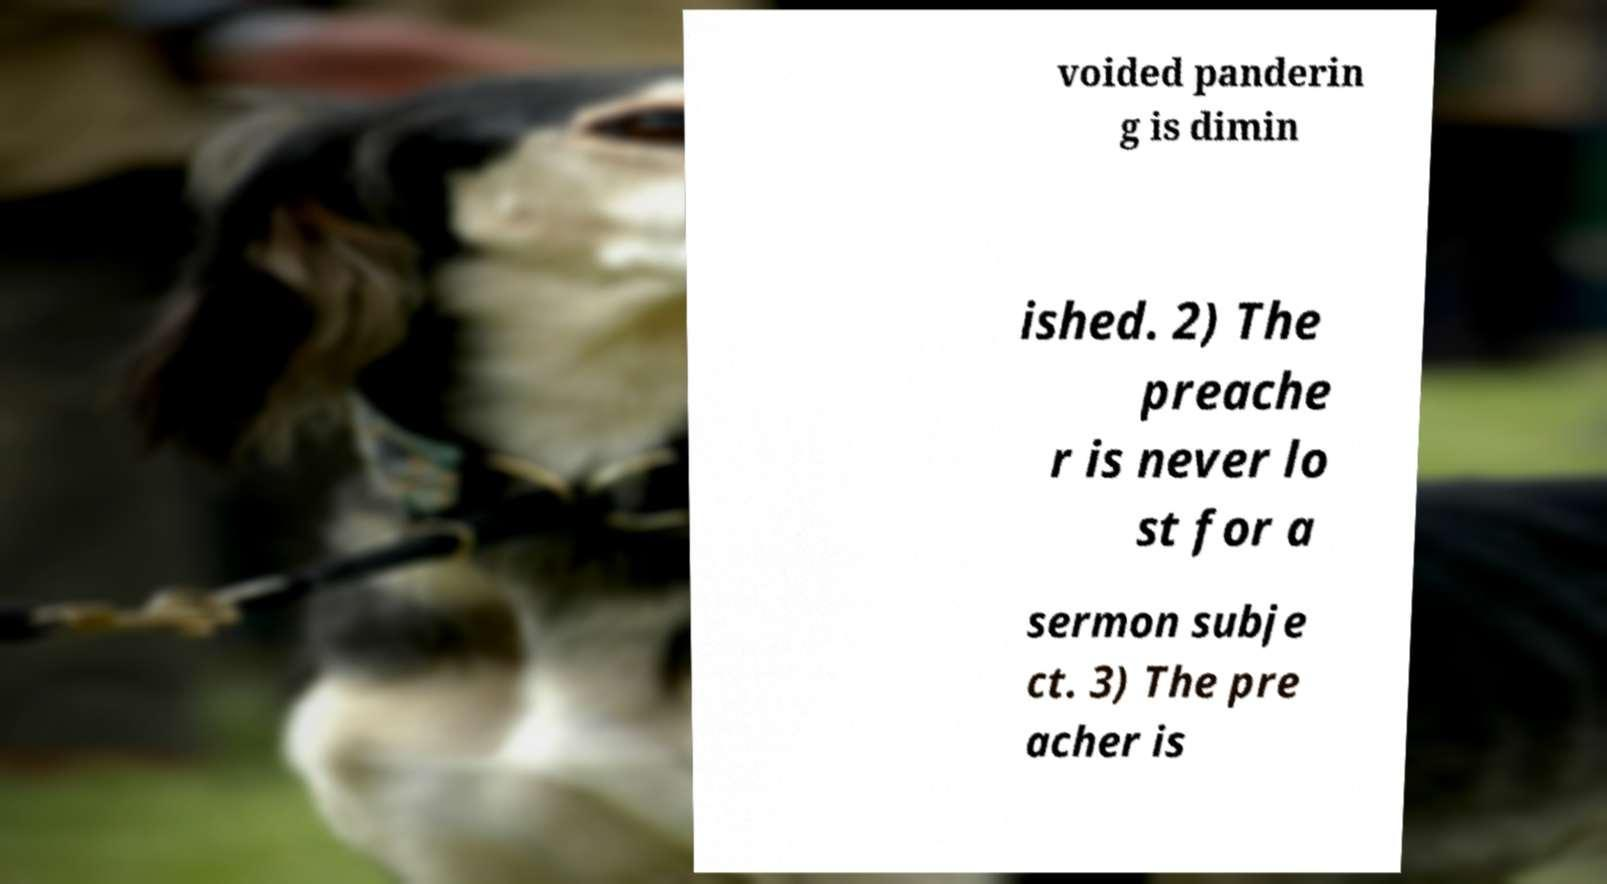For documentation purposes, I need the text within this image transcribed. Could you provide that? voided panderin g is dimin ished. 2) The preache r is never lo st for a sermon subje ct. 3) The pre acher is 